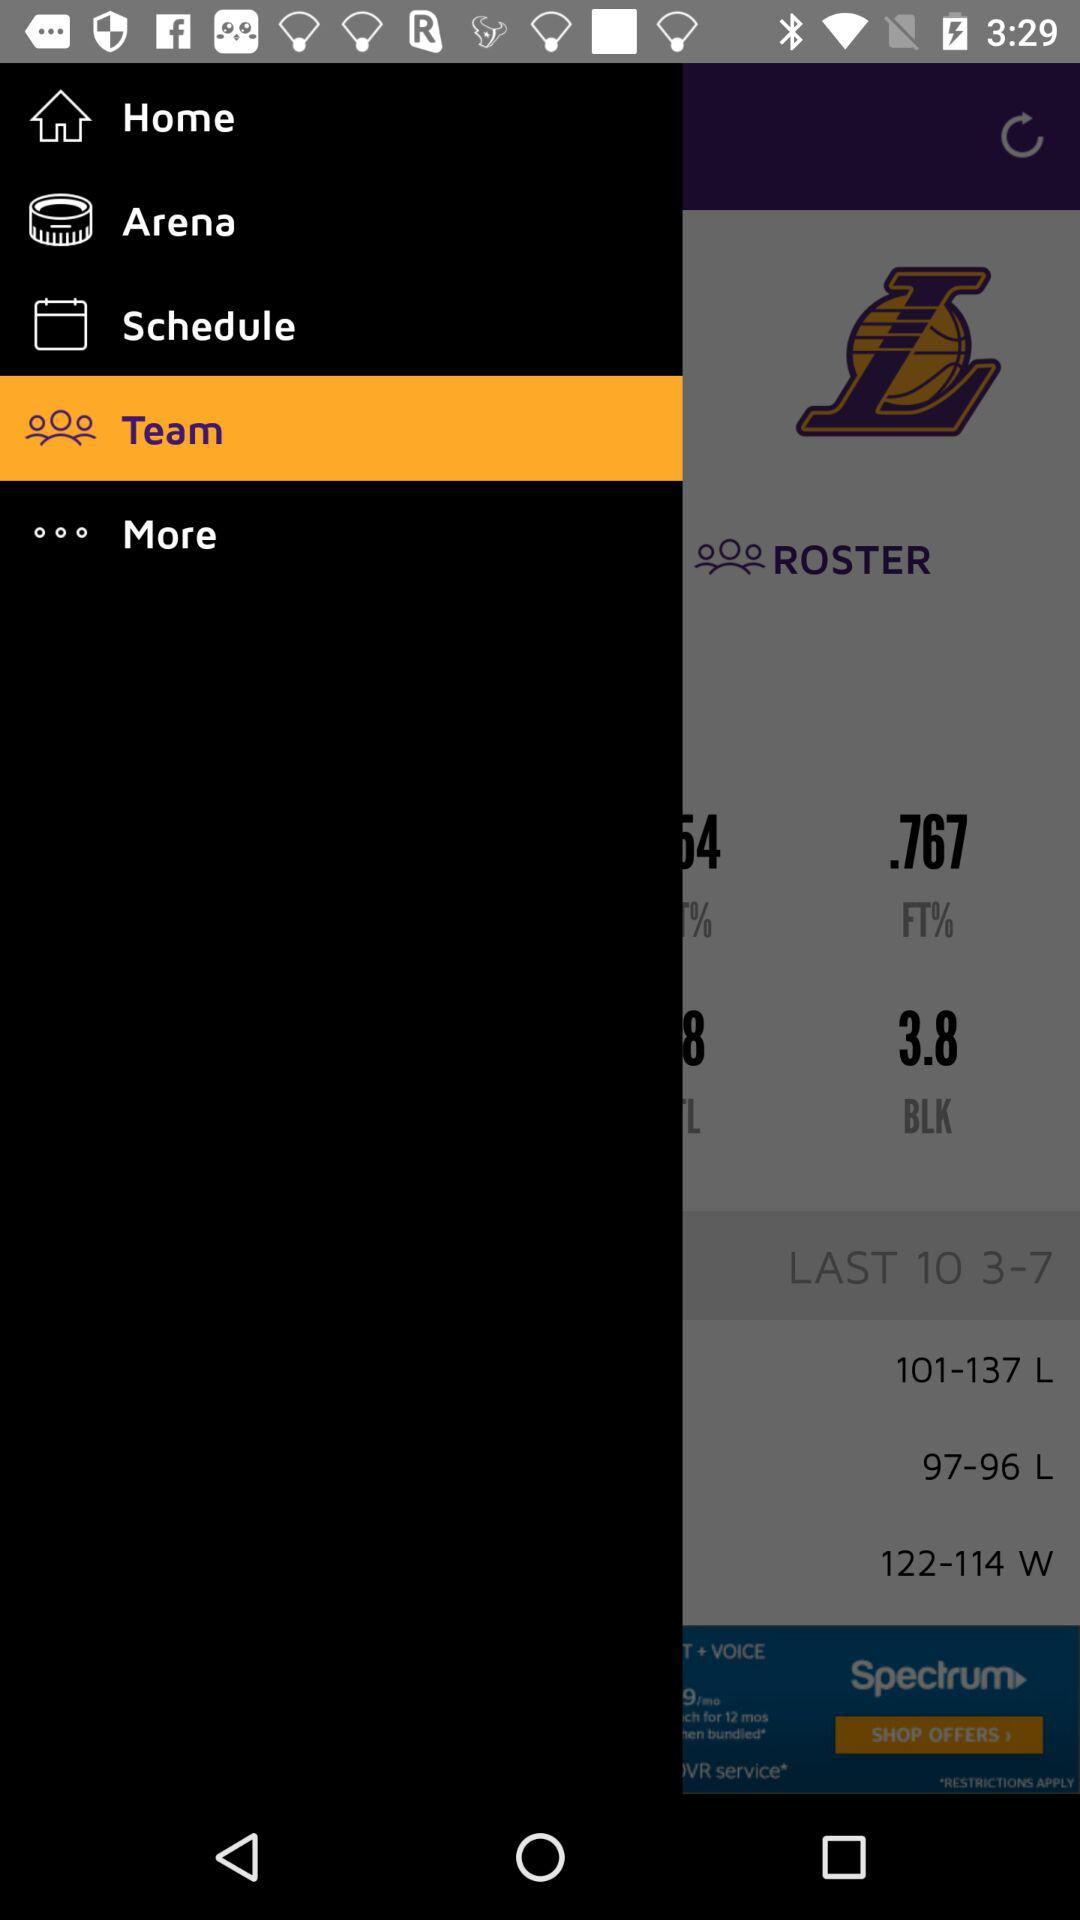How many games have the Lakers won in their last 10?
Answer the question using a single word or phrase. 3 